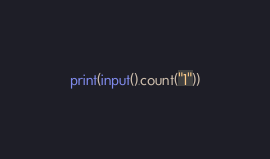<code> <loc_0><loc_0><loc_500><loc_500><_Python_>print(input().count("1"))</code> 